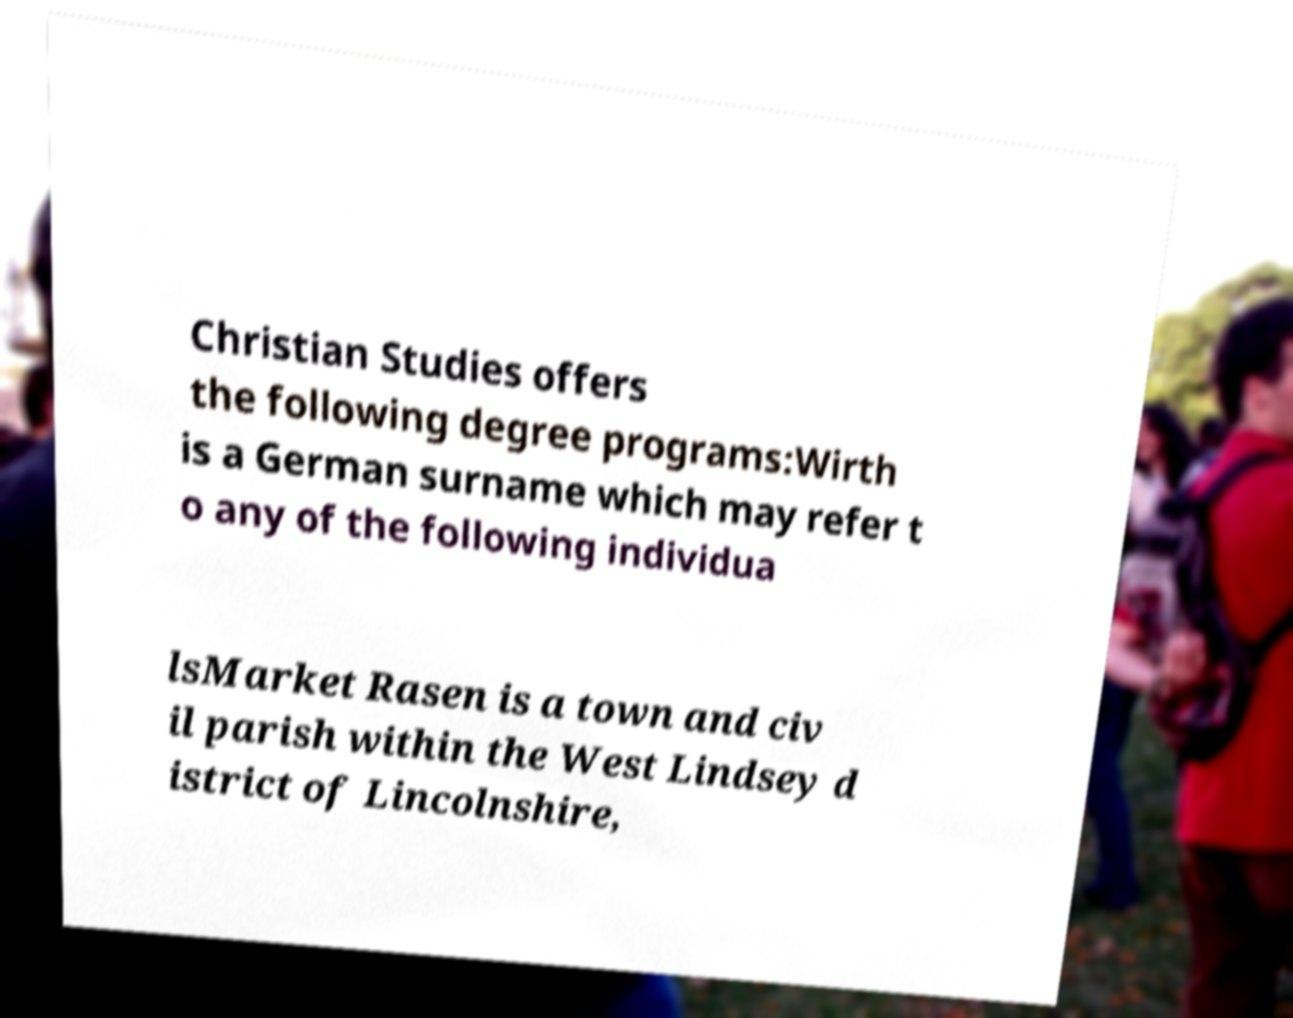Please identify and transcribe the text found in this image. Christian Studies offers the following degree programs:Wirth is a German surname which may refer t o any of the following individua lsMarket Rasen is a town and civ il parish within the West Lindsey d istrict of Lincolnshire, 